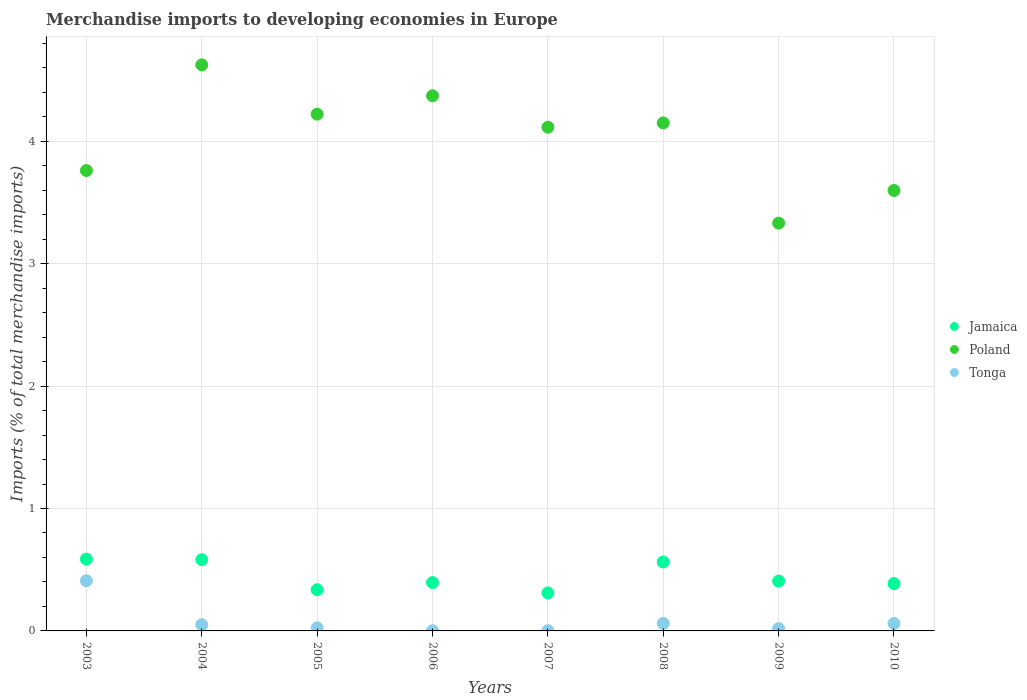How many different coloured dotlines are there?
Keep it short and to the point. 3. What is the percentage total merchandise imports in Poland in 2003?
Offer a very short reply. 3.76. Across all years, what is the maximum percentage total merchandise imports in Poland?
Make the answer very short. 4.62. Across all years, what is the minimum percentage total merchandise imports in Jamaica?
Ensure brevity in your answer.  0.31. In which year was the percentage total merchandise imports in Tonga maximum?
Provide a succinct answer. 2003. In which year was the percentage total merchandise imports in Tonga minimum?
Your answer should be compact. 2006. What is the total percentage total merchandise imports in Jamaica in the graph?
Keep it short and to the point. 3.57. What is the difference between the percentage total merchandise imports in Poland in 2003 and that in 2007?
Provide a short and direct response. -0.35. What is the difference between the percentage total merchandise imports in Jamaica in 2004 and the percentage total merchandise imports in Poland in 2008?
Your answer should be very brief. -3.57. What is the average percentage total merchandise imports in Poland per year?
Offer a terse response. 4.02. In the year 2006, what is the difference between the percentage total merchandise imports in Jamaica and percentage total merchandise imports in Tonga?
Your answer should be compact. 0.39. In how many years, is the percentage total merchandise imports in Tonga greater than 3.8 %?
Your answer should be compact. 0. What is the ratio of the percentage total merchandise imports in Jamaica in 2005 to that in 2009?
Provide a short and direct response. 0.83. Is the percentage total merchandise imports in Poland in 2006 less than that in 2010?
Offer a terse response. No. What is the difference between the highest and the second highest percentage total merchandise imports in Jamaica?
Give a very brief answer. 0. What is the difference between the highest and the lowest percentage total merchandise imports in Poland?
Your answer should be compact. 1.29. Is the percentage total merchandise imports in Poland strictly less than the percentage total merchandise imports in Tonga over the years?
Keep it short and to the point. No. Are the values on the major ticks of Y-axis written in scientific E-notation?
Offer a very short reply. No. Does the graph contain grids?
Give a very brief answer. Yes. Where does the legend appear in the graph?
Provide a short and direct response. Center right. How many legend labels are there?
Make the answer very short. 3. What is the title of the graph?
Your answer should be very brief. Merchandise imports to developing economies in Europe. What is the label or title of the Y-axis?
Make the answer very short. Imports (% of total merchandise imports). What is the Imports (% of total merchandise imports) of Jamaica in 2003?
Provide a short and direct response. 0.59. What is the Imports (% of total merchandise imports) in Poland in 2003?
Keep it short and to the point. 3.76. What is the Imports (% of total merchandise imports) in Tonga in 2003?
Your response must be concise. 0.41. What is the Imports (% of total merchandise imports) in Jamaica in 2004?
Provide a short and direct response. 0.58. What is the Imports (% of total merchandise imports) in Poland in 2004?
Your answer should be compact. 4.62. What is the Imports (% of total merchandise imports) of Tonga in 2004?
Your answer should be compact. 0.05. What is the Imports (% of total merchandise imports) of Jamaica in 2005?
Your answer should be very brief. 0.34. What is the Imports (% of total merchandise imports) of Poland in 2005?
Keep it short and to the point. 4.22. What is the Imports (% of total merchandise imports) of Tonga in 2005?
Give a very brief answer. 0.02. What is the Imports (% of total merchandise imports) of Jamaica in 2006?
Give a very brief answer. 0.39. What is the Imports (% of total merchandise imports) in Poland in 2006?
Offer a terse response. 4.37. What is the Imports (% of total merchandise imports) of Tonga in 2006?
Your response must be concise. 0. What is the Imports (% of total merchandise imports) of Jamaica in 2007?
Offer a terse response. 0.31. What is the Imports (% of total merchandise imports) in Poland in 2007?
Provide a succinct answer. 4.11. What is the Imports (% of total merchandise imports) in Tonga in 2007?
Ensure brevity in your answer.  0. What is the Imports (% of total merchandise imports) of Jamaica in 2008?
Your response must be concise. 0.56. What is the Imports (% of total merchandise imports) of Poland in 2008?
Keep it short and to the point. 4.15. What is the Imports (% of total merchandise imports) in Tonga in 2008?
Your response must be concise. 0.06. What is the Imports (% of total merchandise imports) of Jamaica in 2009?
Provide a succinct answer. 0.41. What is the Imports (% of total merchandise imports) in Poland in 2009?
Your answer should be compact. 3.33. What is the Imports (% of total merchandise imports) of Tonga in 2009?
Provide a succinct answer. 0.02. What is the Imports (% of total merchandise imports) of Jamaica in 2010?
Your answer should be very brief. 0.39. What is the Imports (% of total merchandise imports) in Poland in 2010?
Give a very brief answer. 3.6. What is the Imports (% of total merchandise imports) of Tonga in 2010?
Provide a short and direct response. 0.06. Across all years, what is the maximum Imports (% of total merchandise imports) of Jamaica?
Your response must be concise. 0.59. Across all years, what is the maximum Imports (% of total merchandise imports) of Poland?
Keep it short and to the point. 4.62. Across all years, what is the maximum Imports (% of total merchandise imports) in Tonga?
Offer a very short reply. 0.41. Across all years, what is the minimum Imports (% of total merchandise imports) in Jamaica?
Offer a terse response. 0.31. Across all years, what is the minimum Imports (% of total merchandise imports) of Poland?
Provide a short and direct response. 3.33. Across all years, what is the minimum Imports (% of total merchandise imports) in Tonga?
Offer a terse response. 0. What is the total Imports (% of total merchandise imports) in Jamaica in the graph?
Your answer should be compact. 3.57. What is the total Imports (% of total merchandise imports) of Poland in the graph?
Make the answer very short. 32.17. What is the total Imports (% of total merchandise imports) in Tonga in the graph?
Your answer should be very brief. 0.63. What is the difference between the Imports (% of total merchandise imports) of Jamaica in 2003 and that in 2004?
Provide a short and direct response. 0. What is the difference between the Imports (% of total merchandise imports) in Poland in 2003 and that in 2004?
Offer a terse response. -0.86. What is the difference between the Imports (% of total merchandise imports) of Tonga in 2003 and that in 2004?
Provide a short and direct response. 0.36. What is the difference between the Imports (% of total merchandise imports) of Jamaica in 2003 and that in 2005?
Offer a terse response. 0.25. What is the difference between the Imports (% of total merchandise imports) in Poland in 2003 and that in 2005?
Make the answer very short. -0.46. What is the difference between the Imports (% of total merchandise imports) of Tonga in 2003 and that in 2005?
Give a very brief answer. 0.38. What is the difference between the Imports (% of total merchandise imports) of Jamaica in 2003 and that in 2006?
Give a very brief answer. 0.19. What is the difference between the Imports (% of total merchandise imports) of Poland in 2003 and that in 2006?
Keep it short and to the point. -0.61. What is the difference between the Imports (% of total merchandise imports) in Tonga in 2003 and that in 2006?
Offer a terse response. 0.41. What is the difference between the Imports (% of total merchandise imports) in Jamaica in 2003 and that in 2007?
Give a very brief answer. 0.28. What is the difference between the Imports (% of total merchandise imports) in Poland in 2003 and that in 2007?
Make the answer very short. -0.35. What is the difference between the Imports (% of total merchandise imports) in Tonga in 2003 and that in 2007?
Provide a succinct answer. 0.41. What is the difference between the Imports (% of total merchandise imports) in Jamaica in 2003 and that in 2008?
Ensure brevity in your answer.  0.02. What is the difference between the Imports (% of total merchandise imports) in Poland in 2003 and that in 2008?
Offer a terse response. -0.39. What is the difference between the Imports (% of total merchandise imports) of Tonga in 2003 and that in 2008?
Make the answer very short. 0.35. What is the difference between the Imports (% of total merchandise imports) of Jamaica in 2003 and that in 2009?
Ensure brevity in your answer.  0.18. What is the difference between the Imports (% of total merchandise imports) of Poland in 2003 and that in 2009?
Your answer should be very brief. 0.43. What is the difference between the Imports (% of total merchandise imports) of Tonga in 2003 and that in 2009?
Give a very brief answer. 0.39. What is the difference between the Imports (% of total merchandise imports) of Jamaica in 2003 and that in 2010?
Keep it short and to the point. 0.2. What is the difference between the Imports (% of total merchandise imports) of Poland in 2003 and that in 2010?
Your answer should be very brief. 0.16. What is the difference between the Imports (% of total merchandise imports) of Tonga in 2003 and that in 2010?
Ensure brevity in your answer.  0.35. What is the difference between the Imports (% of total merchandise imports) of Jamaica in 2004 and that in 2005?
Keep it short and to the point. 0.25. What is the difference between the Imports (% of total merchandise imports) in Poland in 2004 and that in 2005?
Keep it short and to the point. 0.4. What is the difference between the Imports (% of total merchandise imports) in Tonga in 2004 and that in 2005?
Make the answer very short. 0.03. What is the difference between the Imports (% of total merchandise imports) in Jamaica in 2004 and that in 2006?
Provide a short and direct response. 0.19. What is the difference between the Imports (% of total merchandise imports) of Poland in 2004 and that in 2006?
Keep it short and to the point. 0.25. What is the difference between the Imports (% of total merchandise imports) in Tonga in 2004 and that in 2006?
Your answer should be compact. 0.05. What is the difference between the Imports (% of total merchandise imports) of Jamaica in 2004 and that in 2007?
Your answer should be very brief. 0.27. What is the difference between the Imports (% of total merchandise imports) in Poland in 2004 and that in 2007?
Ensure brevity in your answer.  0.51. What is the difference between the Imports (% of total merchandise imports) in Tonga in 2004 and that in 2007?
Provide a succinct answer. 0.05. What is the difference between the Imports (% of total merchandise imports) in Jamaica in 2004 and that in 2008?
Make the answer very short. 0.02. What is the difference between the Imports (% of total merchandise imports) in Poland in 2004 and that in 2008?
Your answer should be very brief. 0.47. What is the difference between the Imports (% of total merchandise imports) in Tonga in 2004 and that in 2008?
Offer a terse response. -0.01. What is the difference between the Imports (% of total merchandise imports) of Jamaica in 2004 and that in 2009?
Offer a very short reply. 0.18. What is the difference between the Imports (% of total merchandise imports) of Poland in 2004 and that in 2009?
Offer a terse response. 1.29. What is the difference between the Imports (% of total merchandise imports) of Tonga in 2004 and that in 2009?
Offer a terse response. 0.03. What is the difference between the Imports (% of total merchandise imports) in Jamaica in 2004 and that in 2010?
Your answer should be compact. 0.2. What is the difference between the Imports (% of total merchandise imports) of Poland in 2004 and that in 2010?
Keep it short and to the point. 1.03. What is the difference between the Imports (% of total merchandise imports) of Tonga in 2004 and that in 2010?
Provide a succinct answer. -0.01. What is the difference between the Imports (% of total merchandise imports) of Jamaica in 2005 and that in 2006?
Make the answer very short. -0.06. What is the difference between the Imports (% of total merchandise imports) of Poland in 2005 and that in 2006?
Provide a short and direct response. -0.15. What is the difference between the Imports (% of total merchandise imports) of Tonga in 2005 and that in 2006?
Your response must be concise. 0.02. What is the difference between the Imports (% of total merchandise imports) of Jamaica in 2005 and that in 2007?
Offer a very short reply. 0.03. What is the difference between the Imports (% of total merchandise imports) of Poland in 2005 and that in 2007?
Your response must be concise. 0.11. What is the difference between the Imports (% of total merchandise imports) of Tonga in 2005 and that in 2007?
Keep it short and to the point. 0.02. What is the difference between the Imports (% of total merchandise imports) in Jamaica in 2005 and that in 2008?
Your answer should be very brief. -0.23. What is the difference between the Imports (% of total merchandise imports) in Poland in 2005 and that in 2008?
Provide a short and direct response. 0.07. What is the difference between the Imports (% of total merchandise imports) in Tonga in 2005 and that in 2008?
Make the answer very short. -0.04. What is the difference between the Imports (% of total merchandise imports) of Jamaica in 2005 and that in 2009?
Your answer should be compact. -0.07. What is the difference between the Imports (% of total merchandise imports) of Poland in 2005 and that in 2009?
Provide a short and direct response. 0.89. What is the difference between the Imports (% of total merchandise imports) of Tonga in 2005 and that in 2009?
Ensure brevity in your answer.  0.01. What is the difference between the Imports (% of total merchandise imports) of Jamaica in 2005 and that in 2010?
Offer a very short reply. -0.05. What is the difference between the Imports (% of total merchandise imports) of Poland in 2005 and that in 2010?
Your answer should be compact. 0.62. What is the difference between the Imports (% of total merchandise imports) in Tonga in 2005 and that in 2010?
Offer a terse response. -0.04. What is the difference between the Imports (% of total merchandise imports) in Jamaica in 2006 and that in 2007?
Ensure brevity in your answer.  0.08. What is the difference between the Imports (% of total merchandise imports) of Poland in 2006 and that in 2007?
Offer a very short reply. 0.26. What is the difference between the Imports (% of total merchandise imports) of Tonga in 2006 and that in 2007?
Provide a short and direct response. -0. What is the difference between the Imports (% of total merchandise imports) of Jamaica in 2006 and that in 2008?
Make the answer very short. -0.17. What is the difference between the Imports (% of total merchandise imports) in Poland in 2006 and that in 2008?
Keep it short and to the point. 0.22. What is the difference between the Imports (% of total merchandise imports) of Tonga in 2006 and that in 2008?
Provide a succinct answer. -0.06. What is the difference between the Imports (% of total merchandise imports) of Jamaica in 2006 and that in 2009?
Give a very brief answer. -0.01. What is the difference between the Imports (% of total merchandise imports) in Poland in 2006 and that in 2009?
Keep it short and to the point. 1.04. What is the difference between the Imports (% of total merchandise imports) of Tonga in 2006 and that in 2009?
Offer a very short reply. -0.02. What is the difference between the Imports (% of total merchandise imports) of Jamaica in 2006 and that in 2010?
Make the answer very short. 0.01. What is the difference between the Imports (% of total merchandise imports) in Poland in 2006 and that in 2010?
Make the answer very short. 0.77. What is the difference between the Imports (% of total merchandise imports) in Tonga in 2006 and that in 2010?
Offer a very short reply. -0.06. What is the difference between the Imports (% of total merchandise imports) of Jamaica in 2007 and that in 2008?
Offer a very short reply. -0.25. What is the difference between the Imports (% of total merchandise imports) in Poland in 2007 and that in 2008?
Ensure brevity in your answer.  -0.03. What is the difference between the Imports (% of total merchandise imports) of Tonga in 2007 and that in 2008?
Make the answer very short. -0.06. What is the difference between the Imports (% of total merchandise imports) in Jamaica in 2007 and that in 2009?
Offer a very short reply. -0.1. What is the difference between the Imports (% of total merchandise imports) in Poland in 2007 and that in 2009?
Ensure brevity in your answer.  0.78. What is the difference between the Imports (% of total merchandise imports) of Tonga in 2007 and that in 2009?
Provide a succinct answer. -0.02. What is the difference between the Imports (% of total merchandise imports) in Jamaica in 2007 and that in 2010?
Provide a short and direct response. -0.08. What is the difference between the Imports (% of total merchandise imports) in Poland in 2007 and that in 2010?
Make the answer very short. 0.52. What is the difference between the Imports (% of total merchandise imports) in Tonga in 2007 and that in 2010?
Keep it short and to the point. -0.06. What is the difference between the Imports (% of total merchandise imports) of Jamaica in 2008 and that in 2009?
Make the answer very short. 0.16. What is the difference between the Imports (% of total merchandise imports) in Poland in 2008 and that in 2009?
Provide a short and direct response. 0.82. What is the difference between the Imports (% of total merchandise imports) of Tonga in 2008 and that in 2009?
Offer a terse response. 0.04. What is the difference between the Imports (% of total merchandise imports) of Jamaica in 2008 and that in 2010?
Offer a terse response. 0.18. What is the difference between the Imports (% of total merchandise imports) of Poland in 2008 and that in 2010?
Your answer should be compact. 0.55. What is the difference between the Imports (% of total merchandise imports) in Jamaica in 2009 and that in 2010?
Your answer should be very brief. 0.02. What is the difference between the Imports (% of total merchandise imports) in Poland in 2009 and that in 2010?
Your answer should be compact. -0.27. What is the difference between the Imports (% of total merchandise imports) of Tonga in 2009 and that in 2010?
Give a very brief answer. -0.04. What is the difference between the Imports (% of total merchandise imports) in Jamaica in 2003 and the Imports (% of total merchandise imports) in Poland in 2004?
Give a very brief answer. -4.04. What is the difference between the Imports (% of total merchandise imports) of Jamaica in 2003 and the Imports (% of total merchandise imports) of Tonga in 2004?
Keep it short and to the point. 0.54. What is the difference between the Imports (% of total merchandise imports) in Poland in 2003 and the Imports (% of total merchandise imports) in Tonga in 2004?
Your answer should be very brief. 3.71. What is the difference between the Imports (% of total merchandise imports) of Jamaica in 2003 and the Imports (% of total merchandise imports) of Poland in 2005?
Keep it short and to the point. -3.63. What is the difference between the Imports (% of total merchandise imports) of Jamaica in 2003 and the Imports (% of total merchandise imports) of Tonga in 2005?
Make the answer very short. 0.56. What is the difference between the Imports (% of total merchandise imports) in Poland in 2003 and the Imports (% of total merchandise imports) in Tonga in 2005?
Ensure brevity in your answer.  3.74. What is the difference between the Imports (% of total merchandise imports) of Jamaica in 2003 and the Imports (% of total merchandise imports) of Poland in 2006?
Give a very brief answer. -3.79. What is the difference between the Imports (% of total merchandise imports) of Jamaica in 2003 and the Imports (% of total merchandise imports) of Tonga in 2006?
Your answer should be very brief. 0.58. What is the difference between the Imports (% of total merchandise imports) in Poland in 2003 and the Imports (% of total merchandise imports) in Tonga in 2006?
Your answer should be compact. 3.76. What is the difference between the Imports (% of total merchandise imports) of Jamaica in 2003 and the Imports (% of total merchandise imports) of Poland in 2007?
Provide a succinct answer. -3.53. What is the difference between the Imports (% of total merchandise imports) of Jamaica in 2003 and the Imports (% of total merchandise imports) of Tonga in 2007?
Offer a very short reply. 0.58. What is the difference between the Imports (% of total merchandise imports) in Poland in 2003 and the Imports (% of total merchandise imports) in Tonga in 2007?
Your response must be concise. 3.76. What is the difference between the Imports (% of total merchandise imports) in Jamaica in 2003 and the Imports (% of total merchandise imports) in Poland in 2008?
Ensure brevity in your answer.  -3.56. What is the difference between the Imports (% of total merchandise imports) in Jamaica in 2003 and the Imports (% of total merchandise imports) in Tonga in 2008?
Give a very brief answer. 0.53. What is the difference between the Imports (% of total merchandise imports) in Poland in 2003 and the Imports (% of total merchandise imports) in Tonga in 2008?
Make the answer very short. 3.7. What is the difference between the Imports (% of total merchandise imports) in Jamaica in 2003 and the Imports (% of total merchandise imports) in Poland in 2009?
Ensure brevity in your answer.  -2.74. What is the difference between the Imports (% of total merchandise imports) in Jamaica in 2003 and the Imports (% of total merchandise imports) in Tonga in 2009?
Offer a very short reply. 0.57. What is the difference between the Imports (% of total merchandise imports) in Poland in 2003 and the Imports (% of total merchandise imports) in Tonga in 2009?
Keep it short and to the point. 3.74. What is the difference between the Imports (% of total merchandise imports) in Jamaica in 2003 and the Imports (% of total merchandise imports) in Poland in 2010?
Offer a very short reply. -3.01. What is the difference between the Imports (% of total merchandise imports) of Jamaica in 2003 and the Imports (% of total merchandise imports) of Tonga in 2010?
Offer a terse response. 0.53. What is the difference between the Imports (% of total merchandise imports) of Poland in 2003 and the Imports (% of total merchandise imports) of Tonga in 2010?
Keep it short and to the point. 3.7. What is the difference between the Imports (% of total merchandise imports) of Jamaica in 2004 and the Imports (% of total merchandise imports) of Poland in 2005?
Keep it short and to the point. -3.64. What is the difference between the Imports (% of total merchandise imports) in Jamaica in 2004 and the Imports (% of total merchandise imports) in Tonga in 2005?
Give a very brief answer. 0.56. What is the difference between the Imports (% of total merchandise imports) in Poland in 2004 and the Imports (% of total merchandise imports) in Tonga in 2005?
Your answer should be very brief. 4.6. What is the difference between the Imports (% of total merchandise imports) of Jamaica in 2004 and the Imports (% of total merchandise imports) of Poland in 2006?
Keep it short and to the point. -3.79. What is the difference between the Imports (% of total merchandise imports) of Jamaica in 2004 and the Imports (% of total merchandise imports) of Tonga in 2006?
Offer a terse response. 0.58. What is the difference between the Imports (% of total merchandise imports) in Poland in 2004 and the Imports (% of total merchandise imports) in Tonga in 2006?
Offer a very short reply. 4.62. What is the difference between the Imports (% of total merchandise imports) in Jamaica in 2004 and the Imports (% of total merchandise imports) in Poland in 2007?
Your response must be concise. -3.53. What is the difference between the Imports (% of total merchandise imports) of Jamaica in 2004 and the Imports (% of total merchandise imports) of Tonga in 2007?
Offer a terse response. 0.58. What is the difference between the Imports (% of total merchandise imports) of Poland in 2004 and the Imports (% of total merchandise imports) of Tonga in 2007?
Your answer should be very brief. 4.62. What is the difference between the Imports (% of total merchandise imports) of Jamaica in 2004 and the Imports (% of total merchandise imports) of Poland in 2008?
Your answer should be very brief. -3.57. What is the difference between the Imports (% of total merchandise imports) of Jamaica in 2004 and the Imports (% of total merchandise imports) of Tonga in 2008?
Keep it short and to the point. 0.52. What is the difference between the Imports (% of total merchandise imports) of Poland in 2004 and the Imports (% of total merchandise imports) of Tonga in 2008?
Your answer should be very brief. 4.56. What is the difference between the Imports (% of total merchandise imports) of Jamaica in 2004 and the Imports (% of total merchandise imports) of Poland in 2009?
Provide a short and direct response. -2.75. What is the difference between the Imports (% of total merchandise imports) in Jamaica in 2004 and the Imports (% of total merchandise imports) in Tonga in 2009?
Make the answer very short. 0.56. What is the difference between the Imports (% of total merchandise imports) in Poland in 2004 and the Imports (% of total merchandise imports) in Tonga in 2009?
Provide a succinct answer. 4.61. What is the difference between the Imports (% of total merchandise imports) in Jamaica in 2004 and the Imports (% of total merchandise imports) in Poland in 2010?
Your answer should be compact. -3.02. What is the difference between the Imports (% of total merchandise imports) of Jamaica in 2004 and the Imports (% of total merchandise imports) of Tonga in 2010?
Offer a terse response. 0.52. What is the difference between the Imports (% of total merchandise imports) of Poland in 2004 and the Imports (% of total merchandise imports) of Tonga in 2010?
Make the answer very short. 4.56. What is the difference between the Imports (% of total merchandise imports) of Jamaica in 2005 and the Imports (% of total merchandise imports) of Poland in 2006?
Ensure brevity in your answer.  -4.04. What is the difference between the Imports (% of total merchandise imports) of Jamaica in 2005 and the Imports (% of total merchandise imports) of Tonga in 2006?
Offer a terse response. 0.33. What is the difference between the Imports (% of total merchandise imports) of Poland in 2005 and the Imports (% of total merchandise imports) of Tonga in 2006?
Your answer should be compact. 4.22. What is the difference between the Imports (% of total merchandise imports) in Jamaica in 2005 and the Imports (% of total merchandise imports) in Poland in 2007?
Provide a short and direct response. -3.78. What is the difference between the Imports (% of total merchandise imports) in Jamaica in 2005 and the Imports (% of total merchandise imports) in Tonga in 2007?
Offer a very short reply. 0.33. What is the difference between the Imports (% of total merchandise imports) in Poland in 2005 and the Imports (% of total merchandise imports) in Tonga in 2007?
Keep it short and to the point. 4.22. What is the difference between the Imports (% of total merchandise imports) in Jamaica in 2005 and the Imports (% of total merchandise imports) in Poland in 2008?
Make the answer very short. -3.81. What is the difference between the Imports (% of total merchandise imports) in Jamaica in 2005 and the Imports (% of total merchandise imports) in Tonga in 2008?
Make the answer very short. 0.28. What is the difference between the Imports (% of total merchandise imports) of Poland in 2005 and the Imports (% of total merchandise imports) of Tonga in 2008?
Offer a very short reply. 4.16. What is the difference between the Imports (% of total merchandise imports) of Jamaica in 2005 and the Imports (% of total merchandise imports) of Poland in 2009?
Provide a short and direct response. -2.99. What is the difference between the Imports (% of total merchandise imports) of Jamaica in 2005 and the Imports (% of total merchandise imports) of Tonga in 2009?
Your answer should be very brief. 0.32. What is the difference between the Imports (% of total merchandise imports) in Poland in 2005 and the Imports (% of total merchandise imports) in Tonga in 2009?
Your answer should be compact. 4.2. What is the difference between the Imports (% of total merchandise imports) of Jamaica in 2005 and the Imports (% of total merchandise imports) of Poland in 2010?
Ensure brevity in your answer.  -3.26. What is the difference between the Imports (% of total merchandise imports) of Jamaica in 2005 and the Imports (% of total merchandise imports) of Tonga in 2010?
Your answer should be compact. 0.28. What is the difference between the Imports (% of total merchandise imports) of Poland in 2005 and the Imports (% of total merchandise imports) of Tonga in 2010?
Offer a terse response. 4.16. What is the difference between the Imports (% of total merchandise imports) of Jamaica in 2006 and the Imports (% of total merchandise imports) of Poland in 2007?
Your answer should be very brief. -3.72. What is the difference between the Imports (% of total merchandise imports) of Jamaica in 2006 and the Imports (% of total merchandise imports) of Tonga in 2007?
Keep it short and to the point. 0.39. What is the difference between the Imports (% of total merchandise imports) of Poland in 2006 and the Imports (% of total merchandise imports) of Tonga in 2007?
Give a very brief answer. 4.37. What is the difference between the Imports (% of total merchandise imports) in Jamaica in 2006 and the Imports (% of total merchandise imports) in Poland in 2008?
Ensure brevity in your answer.  -3.75. What is the difference between the Imports (% of total merchandise imports) of Jamaica in 2006 and the Imports (% of total merchandise imports) of Tonga in 2008?
Give a very brief answer. 0.33. What is the difference between the Imports (% of total merchandise imports) in Poland in 2006 and the Imports (% of total merchandise imports) in Tonga in 2008?
Make the answer very short. 4.31. What is the difference between the Imports (% of total merchandise imports) of Jamaica in 2006 and the Imports (% of total merchandise imports) of Poland in 2009?
Provide a succinct answer. -2.94. What is the difference between the Imports (% of total merchandise imports) in Jamaica in 2006 and the Imports (% of total merchandise imports) in Tonga in 2009?
Offer a terse response. 0.38. What is the difference between the Imports (% of total merchandise imports) of Poland in 2006 and the Imports (% of total merchandise imports) of Tonga in 2009?
Provide a short and direct response. 4.35. What is the difference between the Imports (% of total merchandise imports) in Jamaica in 2006 and the Imports (% of total merchandise imports) in Poland in 2010?
Offer a terse response. -3.2. What is the difference between the Imports (% of total merchandise imports) of Jamaica in 2006 and the Imports (% of total merchandise imports) of Tonga in 2010?
Your answer should be very brief. 0.33. What is the difference between the Imports (% of total merchandise imports) in Poland in 2006 and the Imports (% of total merchandise imports) in Tonga in 2010?
Offer a very short reply. 4.31. What is the difference between the Imports (% of total merchandise imports) of Jamaica in 2007 and the Imports (% of total merchandise imports) of Poland in 2008?
Offer a terse response. -3.84. What is the difference between the Imports (% of total merchandise imports) of Jamaica in 2007 and the Imports (% of total merchandise imports) of Tonga in 2008?
Your answer should be very brief. 0.25. What is the difference between the Imports (% of total merchandise imports) of Poland in 2007 and the Imports (% of total merchandise imports) of Tonga in 2008?
Make the answer very short. 4.05. What is the difference between the Imports (% of total merchandise imports) in Jamaica in 2007 and the Imports (% of total merchandise imports) in Poland in 2009?
Offer a terse response. -3.02. What is the difference between the Imports (% of total merchandise imports) in Jamaica in 2007 and the Imports (% of total merchandise imports) in Tonga in 2009?
Offer a very short reply. 0.29. What is the difference between the Imports (% of total merchandise imports) of Poland in 2007 and the Imports (% of total merchandise imports) of Tonga in 2009?
Keep it short and to the point. 4.1. What is the difference between the Imports (% of total merchandise imports) in Jamaica in 2007 and the Imports (% of total merchandise imports) in Poland in 2010?
Your answer should be compact. -3.29. What is the difference between the Imports (% of total merchandise imports) in Jamaica in 2007 and the Imports (% of total merchandise imports) in Tonga in 2010?
Your answer should be compact. 0.25. What is the difference between the Imports (% of total merchandise imports) of Poland in 2007 and the Imports (% of total merchandise imports) of Tonga in 2010?
Provide a succinct answer. 4.05. What is the difference between the Imports (% of total merchandise imports) of Jamaica in 2008 and the Imports (% of total merchandise imports) of Poland in 2009?
Offer a very short reply. -2.77. What is the difference between the Imports (% of total merchandise imports) in Jamaica in 2008 and the Imports (% of total merchandise imports) in Tonga in 2009?
Keep it short and to the point. 0.54. What is the difference between the Imports (% of total merchandise imports) of Poland in 2008 and the Imports (% of total merchandise imports) of Tonga in 2009?
Ensure brevity in your answer.  4.13. What is the difference between the Imports (% of total merchandise imports) in Jamaica in 2008 and the Imports (% of total merchandise imports) in Poland in 2010?
Offer a terse response. -3.03. What is the difference between the Imports (% of total merchandise imports) in Jamaica in 2008 and the Imports (% of total merchandise imports) in Tonga in 2010?
Your answer should be compact. 0.5. What is the difference between the Imports (% of total merchandise imports) in Poland in 2008 and the Imports (% of total merchandise imports) in Tonga in 2010?
Provide a short and direct response. 4.09. What is the difference between the Imports (% of total merchandise imports) in Jamaica in 2009 and the Imports (% of total merchandise imports) in Poland in 2010?
Keep it short and to the point. -3.19. What is the difference between the Imports (% of total merchandise imports) of Jamaica in 2009 and the Imports (% of total merchandise imports) of Tonga in 2010?
Your answer should be compact. 0.35. What is the difference between the Imports (% of total merchandise imports) of Poland in 2009 and the Imports (% of total merchandise imports) of Tonga in 2010?
Provide a succinct answer. 3.27. What is the average Imports (% of total merchandise imports) in Jamaica per year?
Your response must be concise. 0.45. What is the average Imports (% of total merchandise imports) of Poland per year?
Ensure brevity in your answer.  4.02. What is the average Imports (% of total merchandise imports) in Tonga per year?
Your response must be concise. 0.08. In the year 2003, what is the difference between the Imports (% of total merchandise imports) of Jamaica and Imports (% of total merchandise imports) of Poland?
Make the answer very short. -3.17. In the year 2003, what is the difference between the Imports (% of total merchandise imports) in Jamaica and Imports (% of total merchandise imports) in Tonga?
Ensure brevity in your answer.  0.18. In the year 2003, what is the difference between the Imports (% of total merchandise imports) of Poland and Imports (% of total merchandise imports) of Tonga?
Your answer should be very brief. 3.35. In the year 2004, what is the difference between the Imports (% of total merchandise imports) of Jamaica and Imports (% of total merchandise imports) of Poland?
Offer a very short reply. -4.04. In the year 2004, what is the difference between the Imports (% of total merchandise imports) in Jamaica and Imports (% of total merchandise imports) in Tonga?
Make the answer very short. 0.53. In the year 2004, what is the difference between the Imports (% of total merchandise imports) of Poland and Imports (% of total merchandise imports) of Tonga?
Ensure brevity in your answer.  4.57. In the year 2005, what is the difference between the Imports (% of total merchandise imports) in Jamaica and Imports (% of total merchandise imports) in Poland?
Your response must be concise. -3.88. In the year 2005, what is the difference between the Imports (% of total merchandise imports) in Jamaica and Imports (% of total merchandise imports) in Tonga?
Offer a very short reply. 0.31. In the year 2005, what is the difference between the Imports (% of total merchandise imports) in Poland and Imports (% of total merchandise imports) in Tonga?
Offer a very short reply. 4.2. In the year 2006, what is the difference between the Imports (% of total merchandise imports) in Jamaica and Imports (% of total merchandise imports) in Poland?
Provide a succinct answer. -3.98. In the year 2006, what is the difference between the Imports (% of total merchandise imports) in Jamaica and Imports (% of total merchandise imports) in Tonga?
Keep it short and to the point. 0.39. In the year 2006, what is the difference between the Imports (% of total merchandise imports) in Poland and Imports (% of total merchandise imports) in Tonga?
Your response must be concise. 4.37. In the year 2007, what is the difference between the Imports (% of total merchandise imports) in Jamaica and Imports (% of total merchandise imports) in Poland?
Give a very brief answer. -3.8. In the year 2007, what is the difference between the Imports (% of total merchandise imports) in Jamaica and Imports (% of total merchandise imports) in Tonga?
Provide a short and direct response. 0.31. In the year 2007, what is the difference between the Imports (% of total merchandise imports) of Poland and Imports (% of total merchandise imports) of Tonga?
Your answer should be very brief. 4.11. In the year 2008, what is the difference between the Imports (% of total merchandise imports) in Jamaica and Imports (% of total merchandise imports) in Poland?
Give a very brief answer. -3.59. In the year 2008, what is the difference between the Imports (% of total merchandise imports) of Jamaica and Imports (% of total merchandise imports) of Tonga?
Offer a very short reply. 0.5. In the year 2008, what is the difference between the Imports (% of total merchandise imports) in Poland and Imports (% of total merchandise imports) in Tonga?
Make the answer very short. 4.09. In the year 2009, what is the difference between the Imports (% of total merchandise imports) of Jamaica and Imports (% of total merchandise imports) of Poland?
Give a very brief answer. -2.92. In the year 2009, what is the difference between the Imports (% of total merchandise imports) in Jamaica and Imports (% of total merchandise imports) in Tonga?
Offer a terse response. 0.39. In the year 2009, what is the difference between the Imports (% of total merchandise imports) in Poland and Imports (% of total merchandise imports) in Tonga?
Give a very brief answer. 3.31. In the year 2010, what is the difference between the Imports (% of total merchandise imports) in Jamaica and Imports (% of total merchandise imports) in Poland?
Provide a short and direct response. -3.21. In the year 2010, what is the difference between the Imports (% of total merchandise imports) of Jamaica and Imports (% of total merchandise imports) of Tonga?
Offer a terse response. 0.33. In the year 2010, what is the difference between the Imports (% of total merchandise imports) of Poland and Imports (% of total merchandise imports) of Tonga?
Your response must be concise. 3.54. What is the ratio of the Imports (% of total merchandise imports) of Jamaica in 2003 to that in 2004?
Your response must be concise. 1.01. What is the ratio of the Imports (% of total merchandise imports) in Poland in 2003 to that in 2004?
Offer a terse response. 0.81. What is the ratio of the Imports (% of total merchandise imports) of Tonga in 2003 to that in 2004?
Keep it short and to the point. 8.06. What is the ratio of the Imports (% of total merchandise imports) of Jamaica in 2003 to that in 2005?
Ensure brevity in your answer.  1.74. What is the ratio of the Imports (% of total merchandise imports) in Poland in 2003 to that in 2005?
Keep it short and to the point. 0.89. What is the ratio of the Imports (% of total merchandise imports) in Tonga in 2003 to that in 2005?
Your response must be concise. 16.46. What is the ratio of the Imports (% of total merchandise imports) of Jamaica in 2003 to that in 2006?
Offer a very short reply. 1.48. What is the ratio of the Imports (% of total merchandise imports) of Poland in 2003 to that in 2006?
Your answer should be compact. 0.86. What is the ratio of the Imports (% of total merchandise imports) of Tonga in 2003 to that in 2006?
Your response must be concise. 220.58. What is the ratio of the Imports (% of total merchandise imports) in Jamaica in 2003 to that in 2007?
Your response must be concise. 1.89. What is the ratio of the Imports (% of total merchandise imports) of Poland in 2003 to that in 2007?
Provide a succinct answer. 0.91. What is the ratio of the Imports (% of total merchandise imports) in Tonga in 2003 to that in 2007?
Make the answer very short. 214.69. What is the ratio of the Imports (% of total merchandise imports) of Jamaica in 2003 to that in 2008?
Provide a succinct answer. 1.04. What is the ratio of the Imports (% of total merchandise imports) of Poland in 2003 to that in 2008?
Give a very brief answer. 0.91. What is the ratio of the Imports (% of total merchandise imports) in Tonga in 2003 to that in 2008?
Make the answer very short. 6.69. What is the ratio of the Imports (% of total merchandise imports) in Jamaica in 2003 to that in 2009?
Keep it short and to the point. 1.44. What is the ratio of the Imports (% of total merchandise imports) of Poland in 2003 to that in 2009?
Your answer should be compact. 1.13. What is the ratio of the Imports (% of total merchandise imports) of Tonga in 2003 to that in 2009?
Keep it short and to the point. 21.92. What is the ratio of the Imports (% of total merchandise imports) of Jamaica in 2003 to that in 2010?
Keep it short and to the point. 1.52. What is the ratio of the Imports (% of total merchandise imports) in Poland in 2003 to that in 2010?
Keep it short and to the point. 1.05. What is the ratio of the Imports (% of total merchandise imports) of Tonga in 2003 to that in 2010?
Provide a succinct answer. 6.7. What is the ratio of the Imports (% of total merchandise imports) in Jamaica in 2004 to that in 2005?
Your answer should be compact. 1.73. What is the ratio of the Imports (% of total merchandise imports) of Poland in 2004 to that in 2005?
Offer a terse response. 1.1. What is the ratio of the Imports (% of total merchandise imports) of Tonga in 2004 to that in 2005?
Your answer should be very brief. 2.04. What is the ratio of the Imports (% of total merchandise imports) in Jamaica in 2004 to that in 2006?
Keep it short and to the point. 1.47. What is the ratio of the Imports (% of total merchandise imports) of Poland in 2004 to that in 2006?
Your response must be concise. 1.06. What is the ratio of the Imports (% of total merchandise imports) of Tonga in 2004 to that in 2006?
Provide a succinct answer. 27.37. What is the ratio of the Imports (% of total merchandise imports) in Jamaica in 2004 to that in 2007?
Provide a short and direct response. 1.88. What is the ratio of the Imports (% of total merchandise imports) of Poland in 2004 to that in 2007?
Ensure brevity in your answer.  1.12. What is the ratio of the Imports (% of total merchandise imports) in Tonga in 2004 to that in 2007?
Ensure brevity in your answer.  26.64. What is the ratio of the Imports (% of total merchandise imports) of Jamaica in 2004 to that in 2008?
Your answer should be very brief. 1.03. What is the ratio of the Imports (% of total merchandise imports) of Poland in 2004 to that in 2008?
Provide a succinct answer. 1.11. What is the ratio of the Imports (% of total merchandise imports) of Tonga in 2004 to that in 2008?
Offer a very short reply. 0.83. What is the ratio of the Imports (% of total merchandise imports) of Jamaica in 2004 to that in 2009?
Give a very brief answer. 1.43. What is the ratio of the Imports (% of total merchandise imports) of Poland in 2004 to that in 2009?
Provide a succinct answer. 1.39. What is the ratio of the Imports (% of total merchandise imports) of Tonga in 2004 to that in 2009?
Your response must be concise. 2.72. What is the ratio of the Imports (% of total merchandise imports) of Jamaica in 2004 to that in 2010?
Make the answer very short. 1.51. What is the ratio of the Imports (% of total merchandise imports) of Poland in 2004 to that in 2010?
Offer a very short reply. 1.29. What is the ratio of the Imports (% of total merchandise imports) of Tonga in 2004 to that in 2010?
Keep it short and to the point. 0.83. What is the ratio of the Imports (% of total merchandise imports) in Jamaica in 2005 to that in 2006?
Provide a succinct answer. 0.85. What is the ratio of the Imports (% of total merchandise imports) of Poland in 2005 to that in 2006?
Offer a very short reply. 0.97. What is the ratio of the Imports (% of total merchandise imports) of Tonga in 2005 to that in 2006?
Your answer should be very brief. 13.4. What is the ratio of the Imports (% of total merchandise imports) in Jamaica in 2005 to that in 2007?
Make the answer very short. 1.08. What is the ratio of the Imports (% of total merchandise imports) of Poland in 2005 to that in 2007?
Give a very brief answer. 1.03. What is the ratio of the Imports (% of total merchandise imports) in Tonga in 2005 to that in 2007?
Provide a short and direct response. 13.04. What is the ratio of the Imports (% of total merchandise imports) of Jamaica in 2005 to that in 2008?
Make the answer very short. 0.6. What is the ratio of the Imports (% of total merchandise imports) in Poland in 2005 to that in 2008?
Ensure brevity in your answer.  1.02. What is the ratio of the Imports (% of total merchandise imports) in Tonga in 2005 to that in 2008?
Your response must be concise. 0.41. What is the ratio of the Imports (% of total merchandise imports) in Jamaica in 2005 to that in 2009?
Your response must be concise. 0.83. What is the ratio of the Imports (% of total merchandise imports) of Poland in 2005 to that in 2009?
Your response must be concise. 1.27. What is the ratio of the Imports (% of total merchandise imports) of Tonga in 2005 to that in 2009?
Your answer should be compact. 1.33. What is the ratio of the Imports (% of total merchandise imports) in Jamaica in 2005 to that in 2010?
Keep it short and to the point. 0.87. What is the ratio of the Imports (% of total merchandise imports) of Poland in 2005 to that in 2010?
Keep it short and to the point. 1.17. What is the ratio of the Imports (% of total merchandise imports) of Tonga in 2005 to that in 2010?
Your answer should be compact. 0.41. What is the ratio of the Imports (% of total merchandise imports) in Jamaica in 2006 to that in 2007?
Offer a terse response. 1.27. What is the ratio of the Imports (% of total merchandise imports) in Poland in 2006 to that in 2007?
Give a very brief answer. 1.06. What is the ratio of the Imports (% of total merchandise imports) of Tonga in 2006 to that in 2007?
Keep it short and to the point. 0.97. What is the ratio of the Imports (% of total merchandise imports) in Jamaica in 2006 to that in 2008?
Your answer should be compact. 0.7. What is the ratio of the Imports (% of total merchandise imports) of Poland in 2006 to that in 2008?
Your response must be concise. 1.05. What is the ratio of the Imports (% of total merchandise imports) of Tonga in 2006 to that in 2008?
Offer a terse response. 0.03. What is the ratio of the Imports (% of total merchandise imports) of Jamaica in 2006 to that in 2009?
Ensure brevity in your answer.  0.97. What is the ratio of the Imports (% of total merchandise imports) of Poland in 2006 to that in 2009?
Your answer should be very brief. 1.31. What is the ratio of the Imports (% of total merchandise imports) of Tonga in 2006 to that in 2009?
Ensure brevity in your answer.  0.1. What is the ratio of the Imports (% of total merchandise imports) of Jamaica in 2006 to that in 2010?
Provide a short and direct response. 1.02. What is the ratio of the Imports (% of total merchandise imports) in Poland in 2006 to that in 2010?
Make the answer very short. 1.22. What is the ratio of the Imports (% of total merchandise imports) in Tonga in 2006 to that in 2010?
Offer a terse response. 0.03. What is the ratio of the Imports (% of total merchandise imports) of Jamaica in 2007 to that in 2008?
Give a very brief answer. 0.55. What is the ratio of the Imports (% of total merchandise imports) in Tonga in 2007 to that in 2008?
Offer a terse response. 0.03. What is the ratio of the Imports (% of total merchandise imports) of Jamaica in 2007 to that in 2009?
Your answer should be compact. 0.76. What is the ratio of the Imports (% of total merchandise imports) of Poland in 2007 to that in 2009?
Give a very brief answer. 1.24. What is the ratio of the Imports (% of total merchandise imports) in Tonga in 2007 to that in 2009?
Offer a very short reply. 0.1. What is the ratio of the Imports (% of total merchandise imports) of Jamaica in 2007 to that in 2010?
Ensure brevity in your answer.  0.8. What is the ratio of the Imports (% of total merchandise imports) in Poland in 2007 to that in 2010?
Give a very brief answer. 1.14. What is the ratio of the Imports (% of total merchandise imports) of Tonga in 2007 to that in 2010?
Give a very brief answer. 0.03. What is the ratio of the Imports (% of total merchandise imports) of Jamaica in 2008 to that in 2009?
Ensure brevity in your answer.  1.38. What is the ratio of the Imports (% of total merchandise imports) of Poland in 2008 to that in 2009?
Offer a very short reply. 1.25. What is the ratio of the Imports (% of total merchandise imports) in Tonga in 2008 to that in 2009?
Give a very brief answer. 3.28. What is the ratio of the Imports (% of total merchandise imports) in Jamaica in 2008 to that in 2010?
Offer a terse response. 1.46. What is the ratio of the Imports (% of total merchandise imports) of Poland in 2008 to that in 2010?
Your answer should be compact. 1.15. What is the ratio of the Imports (% of total merchandise imports) in Tonga in 2008 to that in 2010?
Your response must be concise. 1. What is the ratio of the Imports (% of total merchandise imports) of Jamaica in 2009 to that in 2010?
Offer a very short reply. 1.05. What is the ratio of the Imports (% of total merchandise imports) in Poland in 2009 to that in 2010?
Offer a terse response. 0.93. What is the ratio of the Imports (% of total merchandise imports) in Tonga in 2009 to that in 2010?
Your answer should be compact. 0.31. What is the difference between the highest and the second highest Imports (% of total merchandise imports) in Jamaica?
Keep it short and to the point. 0. What is the difference between the highest and the second highest Imports (% of total merchandise imports) in Poland?
Offer a terse response. 0.25. What is the difference between the highest and the second highest Imports (% of total merchandise imports) of Tonga?
Offer a very short reply. 0.35. What is the difference between the highest and the lowest Imports (% of total merchandise imports) in Jamaica?
Make the answer very short. 0.28. What is the difference between the highest and the lowest Imports (% of total merchandise imports) of Poland?
Provide a succinct answer. 1.29. What is the difference between the highest and the lowest Imports (% of total merchandise imports) of Tonga?
Keep it short and to the point. 0.41. 